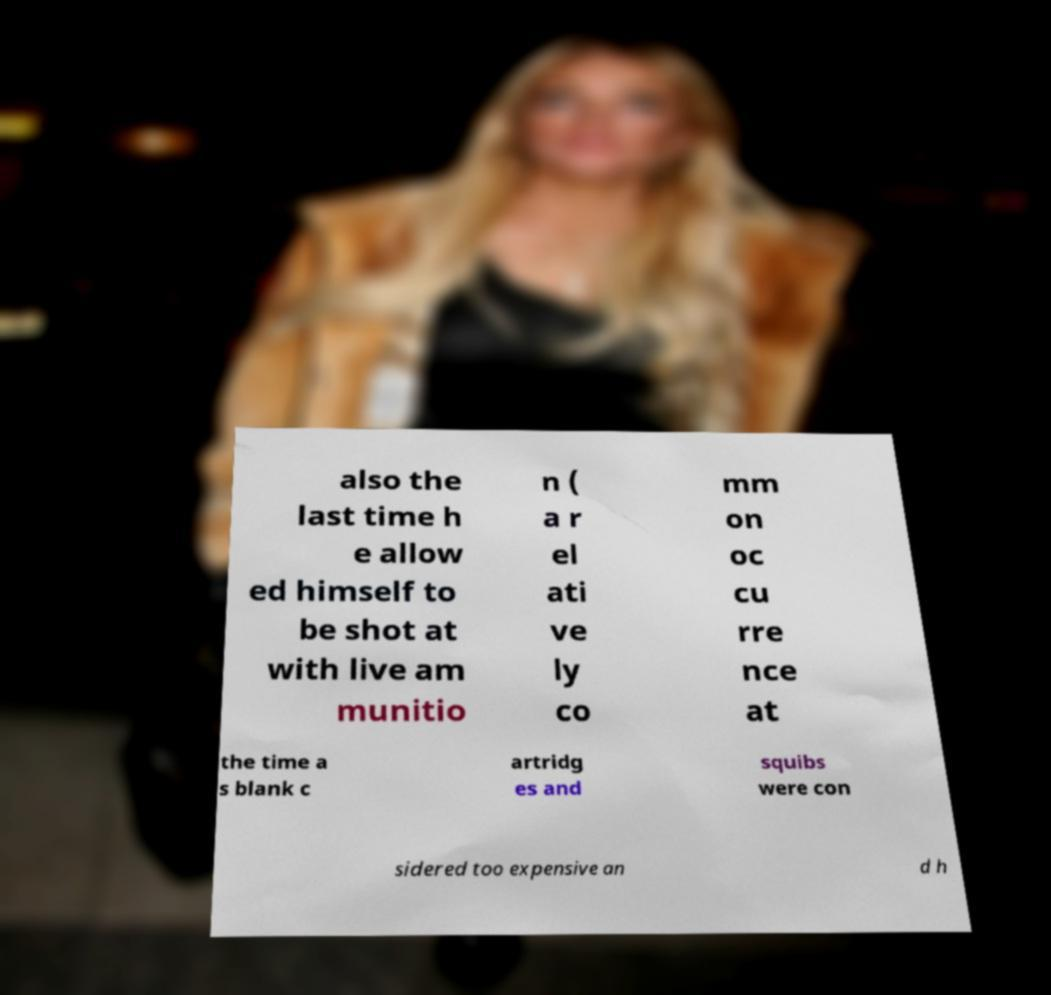Could you extract and type out the text from this image? also the last time h e allow ed himself to be shot at with live am munitio n ( a r el ati ve ly co mm on oc cu rre nce at the time a s blank c artridg es and squibs were con sidered too expensive an d h 